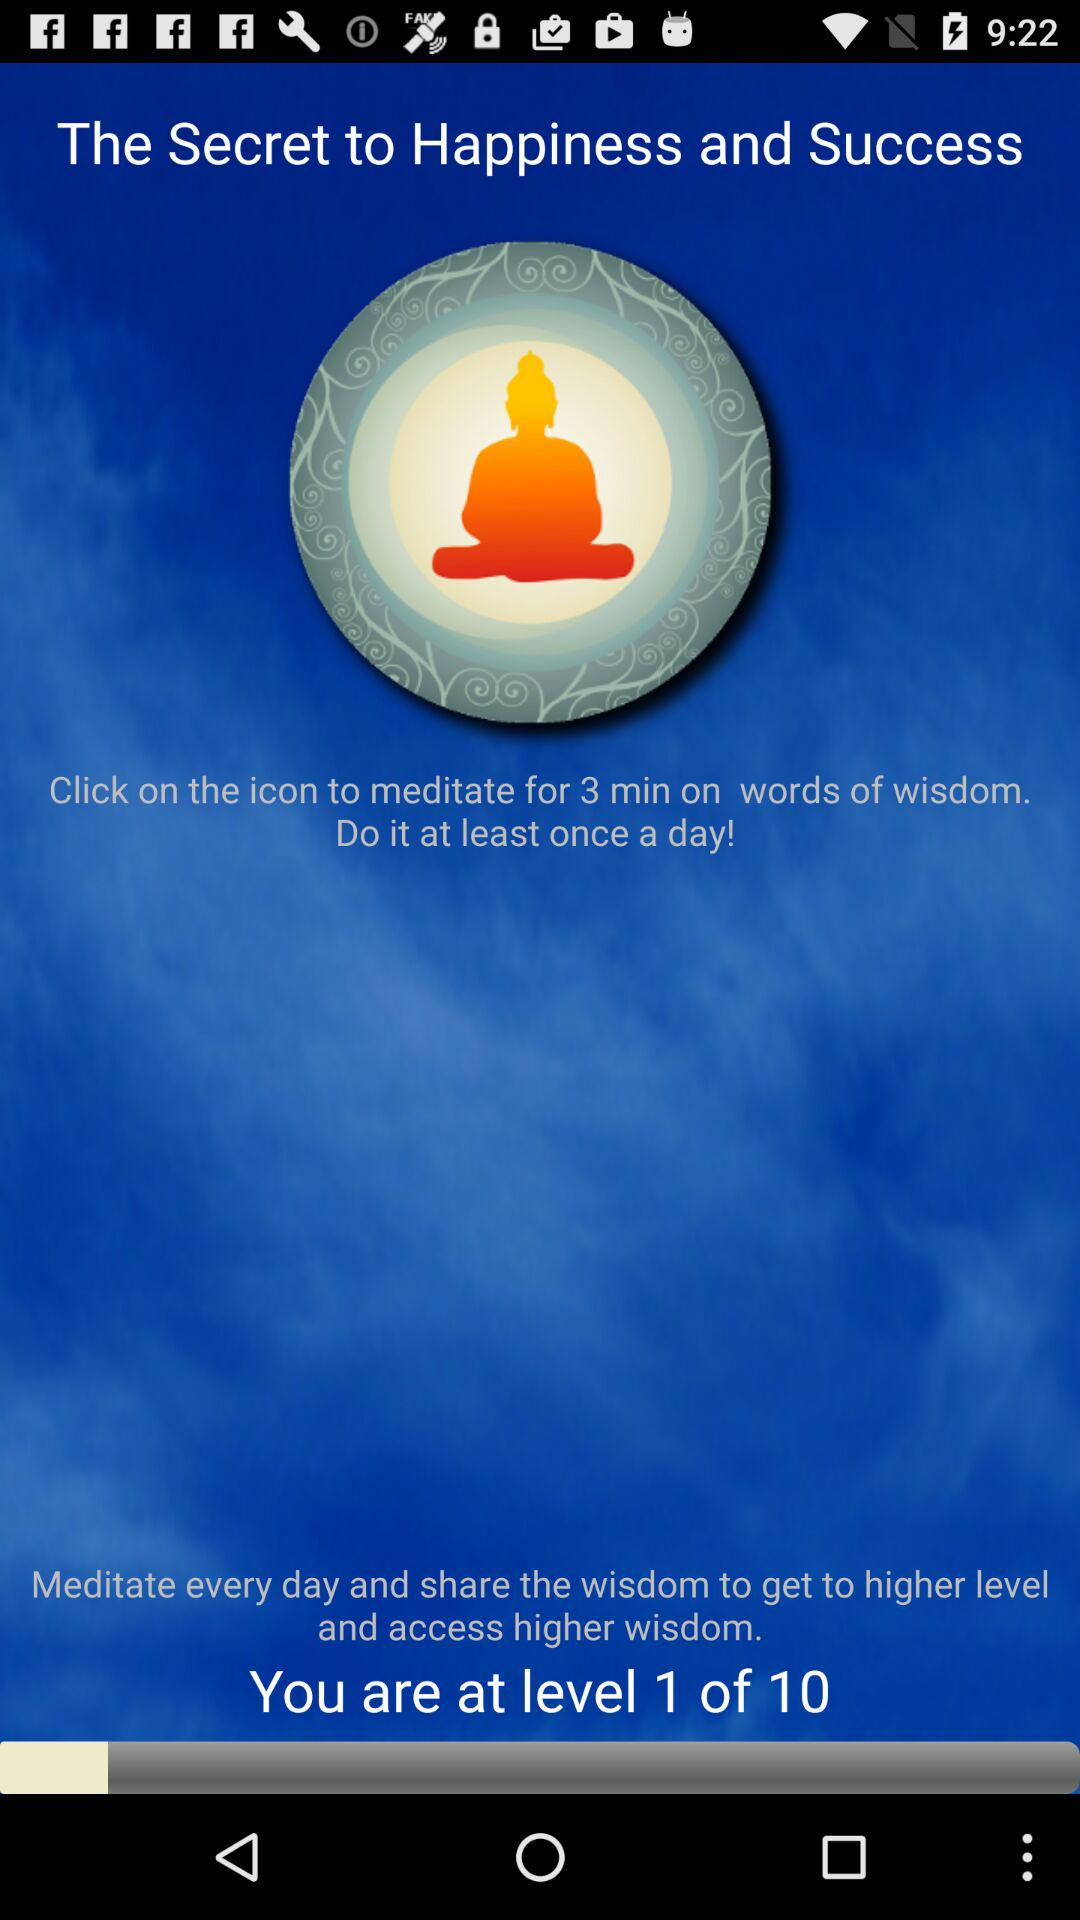How many days does it take to get to level 10?
When the provided information is insufficient, respond with <no answer>. <no answer> 